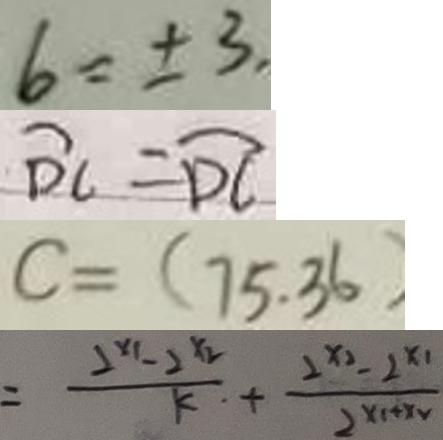<formula> <loc_0><loc_0><loc_500><loc_500>6 = \pm 3 , 
 \widehat { D C } = \widehat { D C } 
 c = ( 7 5 . 3 6 ) 
 = \frac { 2 ^ { x _ { 1 } } - 2 ^ { x _ { 2 } } } { k } + \frac { 1 ^ { x _ { 2 } } - 2 ^ { x _ { 1 } } } { 2 ^ { x _ { 1 } + x _ { 1 } } }</formula> 